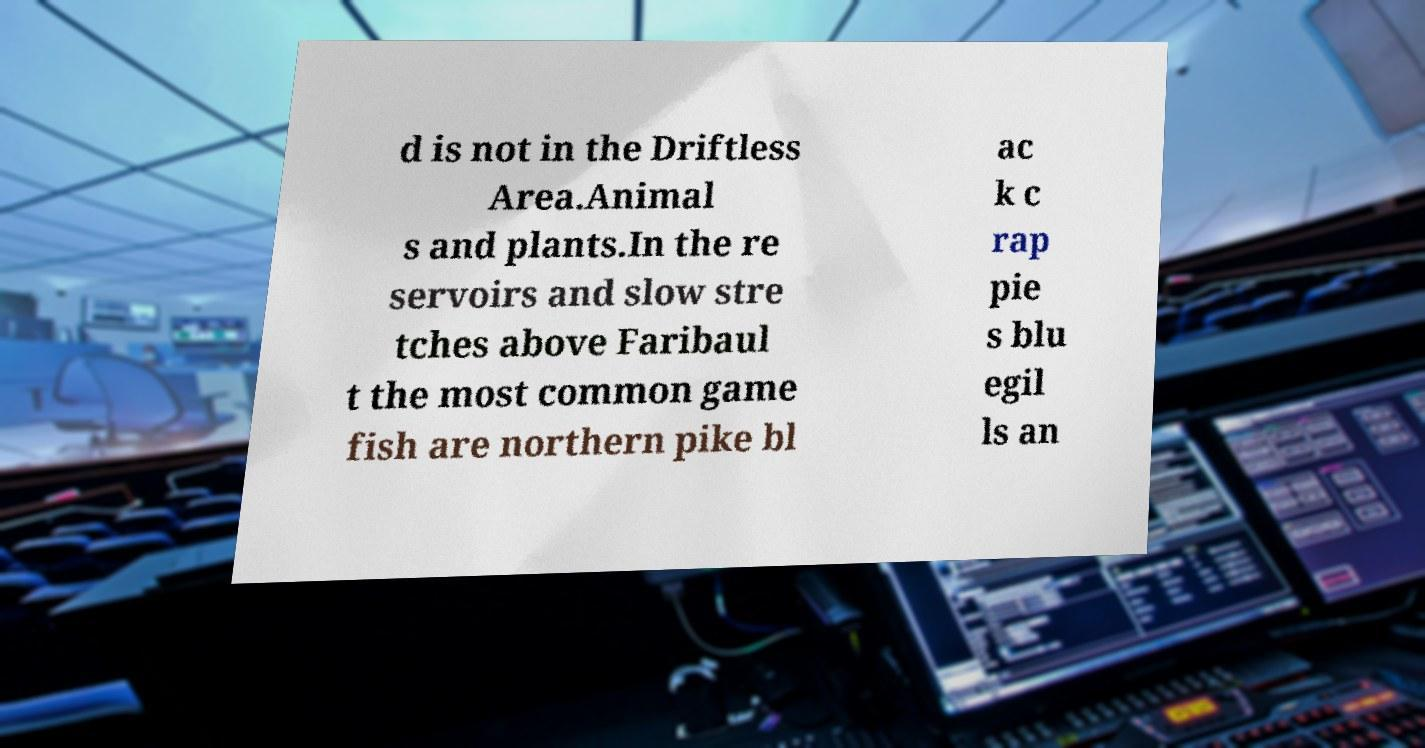Please identify and transcribe the text found in this image. d is not in the Driftless Area.Animal s and plants.In the re servoirs and slow stre tches above Faribaul t the most common game fish are northern pike bl ac k c rap pie s blu egil ls an 